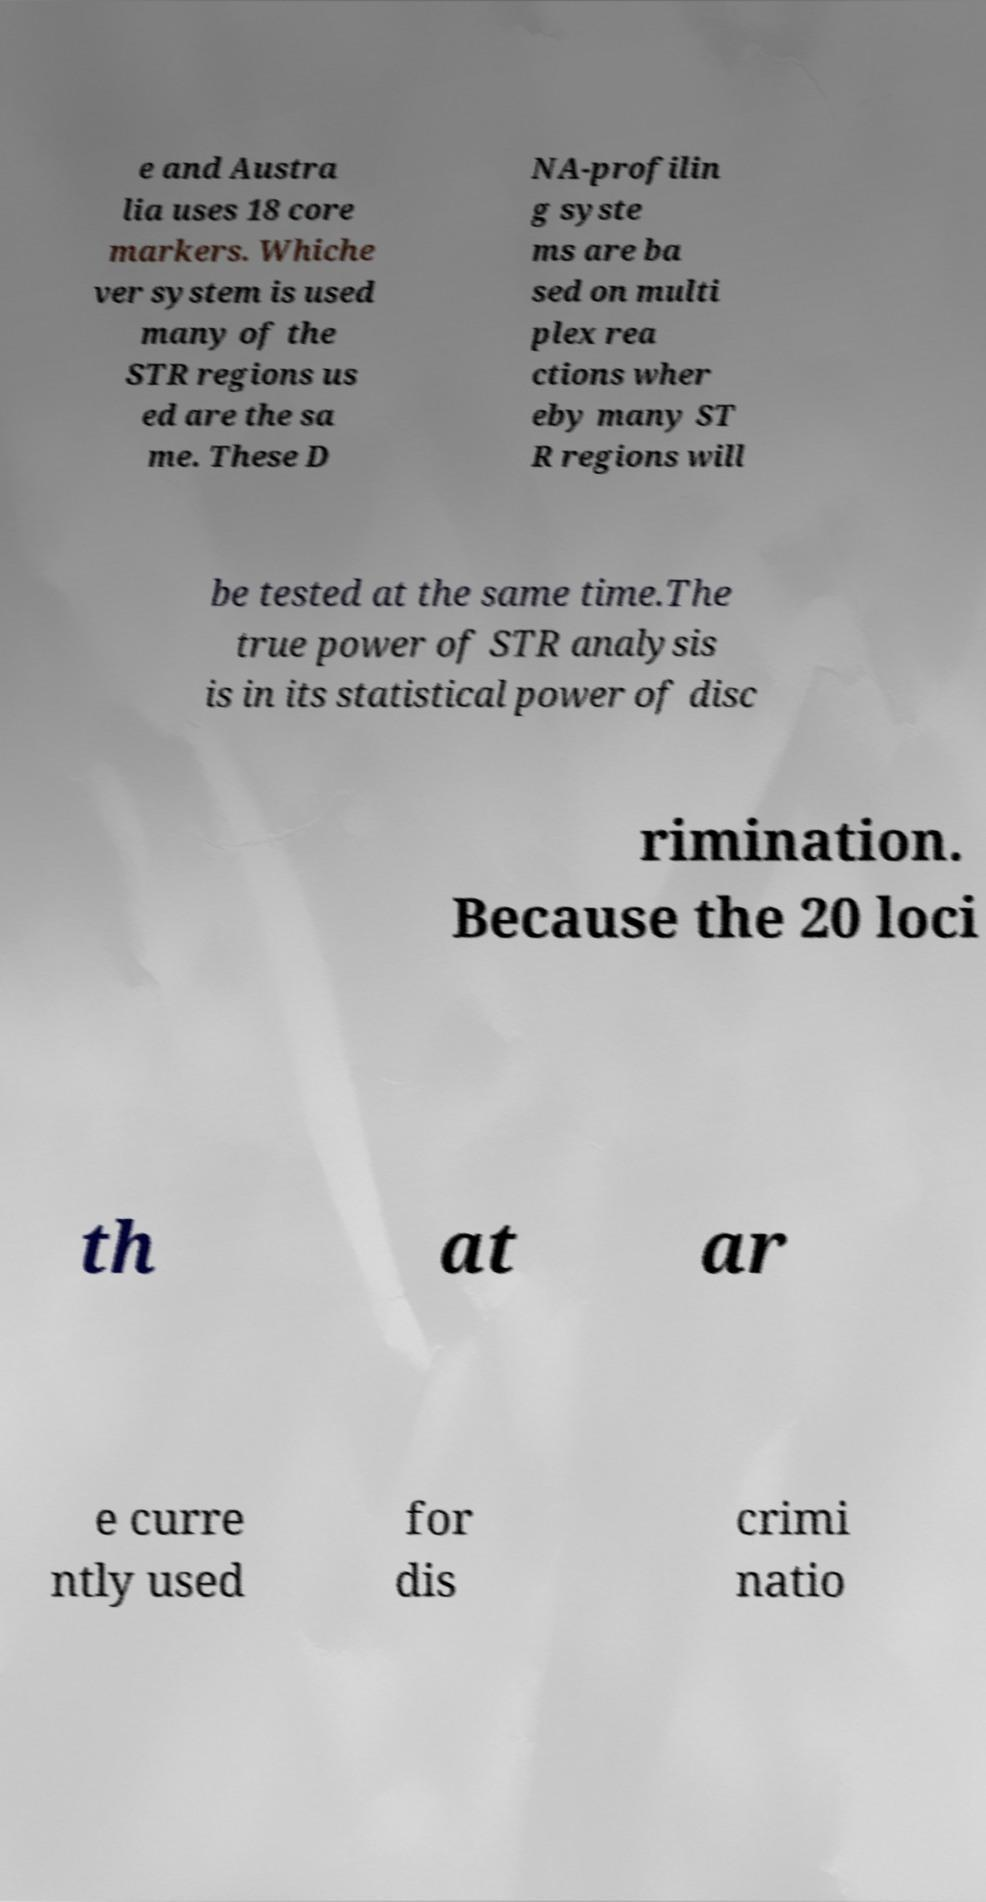Could you extract and type out the text from this image? e and Austra lia uses 18 core markers. Whiche ver system is used many of the STR regions us ed are the sa me. These D NA-profilin g syste ms are ba sed on multi plex rea ctions wher eby many ST R regions will be tested at the same time.The true power of STR analysis is in its statistical power of disc rimination. Because the 20 loci th at ar e curre ntly used for dis crimi natio 